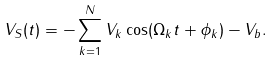<formula> <loc_0><loc_0><loc_500><loc_500>V _ { S } ( t ) = - \sum _ { k = 1 } ^ { N } V _ { k } \cos ( \Omega _ { k } t + \phi _ { k } ) - V _ { b } .</formula> 